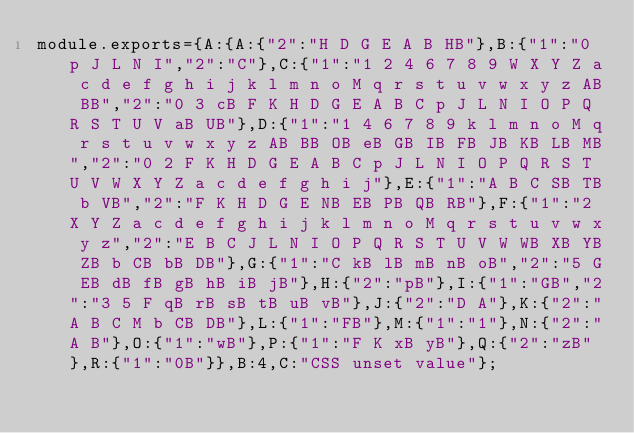<code> <loc_0><loc_0><loc_500><loc_500><_JavaScript_>module.exports={A:{A:{"2":"H D G E A B HB"},B:{"1":"0 p J L N I","2":"C"},C:{"1":"1 2 4 6 7 8 9 W X Y Z a c d e f g h i j k l m n o M q r s t u v w x y z AB BB","2":"0 3 cB F K H D G E A B C p J L N I O P Q R S T U V aB UB"},D:{"1":"1 4 6 7 8 9 k l m n o M q r s t u v w x y z AB BB OB eB GB IB FB JB KB LB MB","2":"0 2 F K H D G E A B C p J L N I O P Q R S T U V W X Y Z a c d e f g h i j"},E:{"1":"A B C SB TB b VB","2":"F K H D G E NB EB PB QB RB"},F:{"1":"2 X Y Z a c d e f g h i j k l m n o M q r s t u v w x y z","2":"E B C J L N I O P Q R S T U V W WB XB YB ZB b CB bB DB"},G:{"1":"C kB lB mB nB oB","2":"5 G EB dB fB gB hB iB jB"},H:{"2":"pB"},I:{"1":"GB","2":"3 5 F qB rB sB tB uB vB"},J:{"2":"D A"},K:{"2":"A B C M b CB DB"},L:{"1":"FB"},M:{"1":"1"},N:{"2":"A B"},O:{"1":"wB"},P:{"1":"F K xB yB"},Q:{"2":"zB"},R:{"1":"0B"}},B:4,C:"CSS unset value"};
</code> 